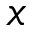<formula> <loc_0><loc_0><loc_500><loc_500>{ x }</formula> 